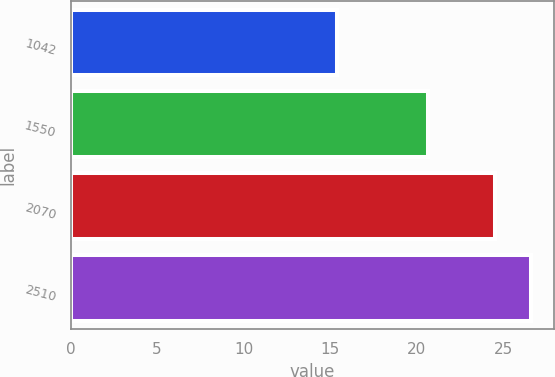<chart> <loc_0><loc_0><loc_500><loc_500><bar_chart><fcel>1042<fcel>1550<fcel>2070<fcel>2510<nl><fcel>15.39<fcel>20.68<fcel>24.51<fcel>26.59<nl></chart> 